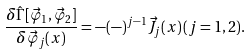<formula> <loc_0><loc_0><loc_500><loc_500>\frac { \delta \hat { \Gamma } [ \vec { \varphi } _ { 1 } , \vec { \varphi } _ { 2 } ] } { \delta \vec { \varphi } _ { j } ( x ) } = - ( - ) ^ { j - 1 } \vec { J } _ { j } ( x ) \, ( j = 1 , 2 ) .</formula> 